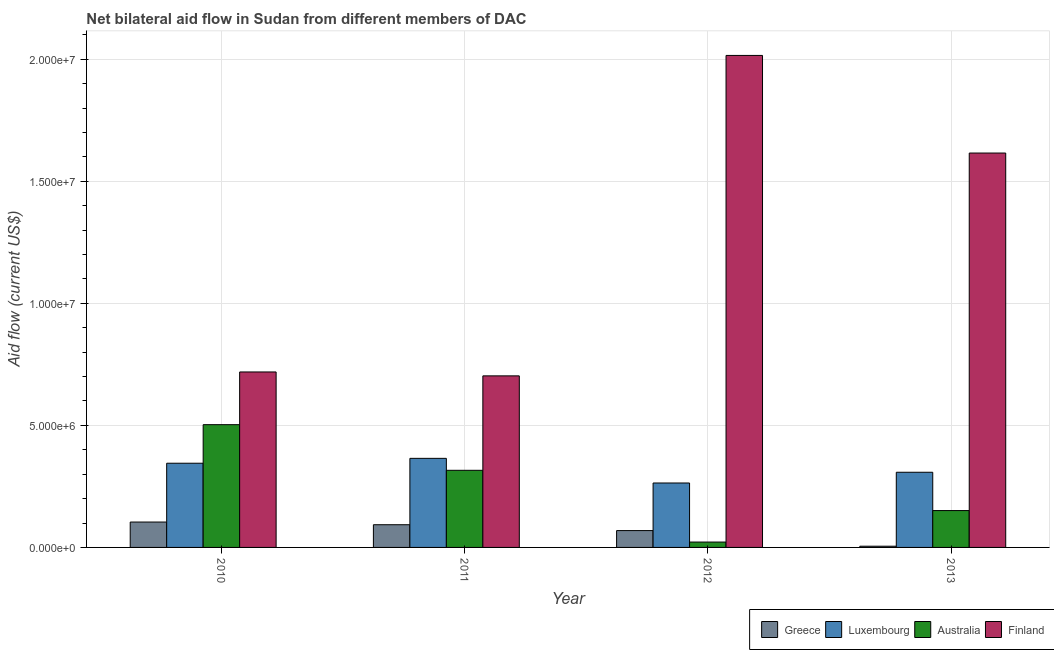How many different coloured bars are there?
Make the answer very short. 4. Are the number of bars on each tick of the X-axis equal?
Your response must be concise. Yes. In how many cases, is the number of bars for a given year not equal to the number of legend labels?
Provide a succinct answer. 0. What is the amount of aid given by australia in 2011?
Provide a succinct answer. 3.16e+06. Across all years, what is the maximum amount of aid given by luxembourg?
Ensure brevity in your answer.  3.65e+06. Across all years, what is the minimum amount of aid given by luxembourg?
Give a very brief answer. 2.64e+06. In which year was the amount of aid given by australia maximum?
Make the answer very short. 2010. In which year was the amount of aid given by luxembourg minimum?
Your answer should be compact. 2012. What is the total amount of aid given by greece in the graph?
Keep it short and to the point. 2.71e+06. What is the difference between the amount of aid given by greece in 2011 and that in 2012?
Your response must be concise. 2.40e+05. What is the difference between the amount of aid given by finland in 2013 and the amount of aid given by greece in 2012?
Your response must be concise. -4.00e+06. What is the average amount of aid given by luxembourg per year?
Your answer should be compact. 3.20e+06. In the year 2012, what is the difference between the amount of aid given by finland and amount of aid given by greece?
Keep it short and to the point. 0. What is the ratio of the amount of aid given by luxembourg in 2010 to that in 2013?
Keep it short and to the point. 1.12. Is the amount of aid given by luxembourg in 2010 less than that in 2011?
Your answer should be compact. Yes. Is the difference between the amount of aid given by greece in 2010 and 2013 greater than the difference between the amount of aid given by luxembourg in 2010 and 2013?
Ensure brevity in your answer.  No. What is the difference between the highest and the second highest amount of aid given by finland?
Offer a terse response. 4.00e+06. What is the difference between the highest and the lowest amount of aid given by luxembourg?
Your answer should be compact. 1.01e+06. In how many years, is the amount of aid given by greece greater than the average amount of aid given by greece taken over all years?
Ensure brevity in your answer.  3. Is the sum of the amount of aid given by luxembourg in 2012 and 2013 greater than the maximum amount of aid given by greece across all years?
Your answer should be very brief. Yes. Is it the case that in every year, the sum of the amount of aid given by finland and amount of aid given by greece is greater than the sum of amount of aid given by australia and amount of aid given by luxembourg?
Your response must be concise. Yes. What does the 4th bar from the right in 2013 represents?
Your answer should be very brief. Greece. Is it the case that in every year, the sum of the amount of aid given by greece and amount of aid given by luxembourg is greater than the amount of aid given by australia?
Offer a terse response. No. Are all the bars in the graph horizontal?
Your answer should be compact. No. How many years are there in the graph?
Offer a terse response. 4. What is the difference between two consecutive major ticks on the Y-axis?
Make the answer very short. 5.00e+06. Are the values on the major ticks of Y-axis written in scientific E-notation?
Offer a very short reply. Yes. Does the graph contain any zero values?
Offer a very short reply. No. Does the graph contain grids?
Give a very brief answer. Yes. How many legend labels are there?
Keep it short and to the point. 4. How are the legend labels stacked?
Give a very brief answer. Horizontal. What is the title of the graph?
Your answer should be very brief. Net bilateral aid flow in Sudan from different members of DAC. Does "UNPBF" appear as one of the legend labels in the graph?
Offer a terse response. No. What is the label or title of the X-axis?
Keep it short and to the point. Year. What is the label or title of the Y-axis?
Offer a terse response. Aid flow (current US$). What is the Aid flow (current US$) in Greece in 2010?
Offer a very short reply. 1.04e+06. What is the Aid flow (current US$) of Luxembourg in 2010?
Ensure brevity in your answer.  3.45e+06. What is the Aid flow (current US$) in Australia in 2010?
Provide a short and direct response. 5.03e+06. What is the Aid flow (current US$) of Finland in 2010?
Keep it short and to the point. 7.19e+06. What is the Aid flow (current US$) in Greece in 2011?
Make the answer very short. 9.30e+05. What is the Aid flow (current US$) in Luxembourg in 2011?
Provide a short and direct response. 3.65e+06. What is the Aid flow (current US$) in Australia in 2011?
Make the answer very short. 3.16e+06. What is the Aid flow (current US$) in Finland in 2011?
Give a very brief answer. 7.03e+06. What is the Aid flow (current US$) of Greece in 2012?
Keep it short and to the point. 6.90e+05. What is the Aid flow (current US$) of Luxembourg in 2012?
Provide a short and direct response. 2.64e+06. What is the Aid flow (current US$) in Finland in 2012?
Provide a short and direct response. 2.02e+07. What is the Aid flow (current US$) in Luxembourg in 2013?
Ensure brevity in your answer.  3.08e+06. What is the Aid flow (current US$) of Australia in 2013?
Ensure brevity in your answer.  1.51e+06. What is the Aid flow (current US$) of Finland in 2013?
Make the answer very short. 1.62e+07. Across all years, what is the maximum Aid flow (current US$) in Greece?
Ensure brevity in your answer.  1.04e+06. Across all years, what is the maximum Aid flow (current US$) of Luxembourg?
Your response must be concise. 3.65e+06. Across all years, what is the maximum Aid flow (current US$) of Australia?
Your answer should be compact. 5.03e+06. Across all years, what is the maximum Aid flow (current US$) in Finland?
Make the answer very short. 2.02e+07. Across all years, what is the minimum Aid flow (current US$) in Luxembourg?
Keep it short and to the point. 2.64e+06. Across all years, what is the minimum Aid flow (current US$) of Australia?
Ensure brevity in your answer.  2.20e+05. Across all years, what is the minimum Aid flow (current US$) in Finland?
Ensure brevity in your answer.  7.03e+06. What is the total Aid flow (current US$) of Greece in the graph?
Your answer should be very brief. 2.71e+06. What is the total Aid flow (current US$) of Luxembourg in the graph?
Your response must be concise. 1.28e+07. What is the total Aid flow (current US$) of Australia in the graph?
Make the answer very short. 9.92e+06. What is the total Aid flow (current US$) of Finland in the graph?
Provide a succinct answer. 5.05e+07. What is the difference between the Aid flow (current US$) of Australia in 2010 and that in 2011?
Provide a succinct answer. 1.87e+06. What is the difference between the Aid flow (current US$) in Greece in 2010 and that in 2012?
Provide a succinct answer. 3.50e+05. What is the difference between the Aid flow (current US$) of Luxembourg in 2010 and that in 2012?
Your response must be concise. 8.10e+05. What is the difference between the Aid flow (current US$) in Australia in 2010 and that in 2012?
Give a very brief answer. 4.81e+06. What is the difference between the Aid flow (current US$) of Finland in 2010 and that in 2012?
Offer a terse response. -1.30e+07. What is the difference between the Aid flow (current US$) of Greece in 2010 and that in 2013?
Keep it short and to the point. 9.90e+05. What is the difference between the Aid flow (current US$) in Australia in 2010 and that in 2013?
Give a very brief answer. 3.52e+06. What is the difference between the Aid flow (current US$) in Finland in 2010 and that in 2013?
Provide a short and direct response. -8.97e+06. What is the difference between the Aid flow (current US$) in Greece in 2011 and that in 2012?
Offer a very short reply. 2.40e+05. What is the difference between the Aid flow (current US$) of Luxembourg in 2011 and that in 2012?
Give a very brief answer. 1.01e+06. What is the difference between the Aid flow (current US$) of Australia in 2011 and that in 2012?
Your response must be concise. 2.94e+06. What is the difference between the Aid flow (current US$) of Finland in 2011 and that in 2012?
Offer a very short reply. -1.31e+07. What is the difference between the Aid flow (current US$) of Greece in 2011 and that in 2013?
Your response must be concise. 8.80e+05. What is the difference between the Aid flow (current US$) in Luxembourg in 2011 and that in 2013?
Ensure brevity in your answer.  5.70e+05. What is the difference between the Aid flow (current US$) in Australia in 2011 and that in 2013?
Give a very brief answer. 1.65e+06. What is the difference between the Aid flow (current US$) in Finland in 2011 and that in 2013?
Your response must be concise. -9.13e+06. What is the difference between the Aid flow (current US$) of Greece in 2012 and that in 2013?
Offer a very short reply. 6.40e+05. What is the difference between the Aid flow (current US$) of Luxembourg in 2012 and that in 2013?
Your answer should be very brief. -4.40e+05. What is the difference between the Aid flow (current US$) of Australia in 2012 and that in 2013?
Your answer should be compact. -1.29e+06. What is the difference between the Aid flow (current US$) of Greece in 2010 and the Aid flow (current US$) of Luxembourg in 2011?
Provide a short and direct response. -2.61e+06. What is the difference between the Aid flow (current US$) in Greece in 2010 and the Aid flow (current US$) in Australia in 2011?
Offer a very short reply. -2.12e+06. What is the difference between the Aid flow (current US$) of Greece in 2010 and the Aid flow (current US$) of Finland in 2011?
Make the answer very short. -5.99e+06. What is the difference between the Aid flow (current US$) in Luxembourg in 2010 and the Aid flow (current US$) in Finland in 2011?
Offer a terse response. -3.58e+06. What is the difference between the Aid flow (current US$) of Greece in 2010 and the Aid flow (current US$) of Luxembourg in 2012?
Your answer should be compact. -1.60e+06. What is the difference between the Aid flow (current US$) in Greece in 2010 and the Aid flow (current US$) in Australia in 2012?
Offer a very short reply. 8.20e+05. What is the difference between the Aid flow (current US$) of Greece in 2010 and the Aid flow (current US$) of Finland in 2012?
Keep it short and to the point. -1.91e+07. What is the difference between the Aid flow (current US$) in Luxembourg in 2010 and the Aid flow (current US$) in Australia in 2012?
Offer a very short reply. 3.23e+06. What is the difference between the Aid flow (current US$) of Luxembourg in 2010 and the Aid flow (current US$) of Finland in 2012?
Provide a short and direct response. -1.67e+07. What is the difference between the Aid flow (current US$) of Australia in 2010 and the Aid flow (current US$) of Finland in 2012?
Make the answer very short. -1.51e+07. What is the difference between the Aid flow (current US$) in Greece in 2010 and the Aid flow (current US$) in Luxembourg in 2013?
Give a very brief answer. -2.04e+06. What is the difference between the Aid flow (current US$) in Greece in 2010 and the Aid flow (current US$) in Australia in 2013?
Keep it short and to the point. -4.70e+05. What is the difference between the Aid flow (current US$) in Greece in 2010 and the Aid flow (current US$) in Finland in 2013?
Offer a terse response. -1.51e+07. What is the difference between the Aid flow (current US$) in Luxembourg in 2010 and the Aid flow (current US$) in Australia in 2013?
Provide a succinct answer. 1.94e+06. What is the difference between the Aid flow (current US$) of Luxembourg in 2010 and the Aid flow (current US$) of Finland in 2013?
Keep it short and to the point. -1.27e+07. What is the difference between the Aid flow (current US$) of Australia in 2010 and the Aid flow (current US$) of Finland in 2013?
Give a very brief answer. -1.11e+07. What is the difference between the Aid flow (current US$) of Greece in 2011 and the Aid flow (current US$) of Luxembourg in 2012?
Your response must be concise. -1.71e+06. What is the difference between the Aid flow (current US$) of Greece in 2011 and the Aid flow (current US$) of Australia in 2012?
Give a very brief answer. 7.10e+05. What is the difference between the Aid flow (current US$) of Greece in 2011 and the Aid flow (current US$) of Finland in 2012?
Ensure brevity in your answer.  -1.92e+07. What is the difference between the Aid flow (current US$) of Luxembourg in 2011 and the Aid flow (current US$) of Australia in 2012?
Offer a terse response. 3.43e+06. What is the difference between the Aid flow (current US$) of Luxembourg in 2011 and the Aid flow (current US$) of Finland in 2012?
Make the answer very short. -1.65e+07. What is the difference between the Aid flow (current US$) in Australia in 2011 and the Aid flow (current US$) in Finland in 2012?
Your answer should be compact. -1.70e+07. What is the difference between the Aid flow (current US$) of Greece in 2011 and the Aid flow (current US$) of Luxembourg in 2013?
Offer a very short reply. -2.15e+06. What is the difference between the Aid flow (current US$) of Greece in 2011 and the Aid flow (current US$) of Australia in 2013?
Offer a very short reply. -5.80e+05. What is the difference between the Aid flow (current US$) of Greece in 2011 and the Aid flow (current US$) of Finland in 2013?
Offer a terse response. -1.52e+07. What is the difference between the Aid flow (current US$) of Luxembourg in 2011 and the Aid flow (current US$) of Australia in 2013?
Provide a succinct answer. 2.14e+06. What is the difference between the Aid flow (current US$) of Luxembourg in 2011 and the Aid flow (current US$) of Finland in 2013?
Your answer should be very brief. -1.25e+07. What is the difference between the Aid flow (current US$) in Australia in 2011 and the Aid flow (current US$) in Finland in 2013?
Provide a succinct answer. -1.30e+07. What is the difference between the Aid flow (current US$) of Greece in 2012 and the Aid flow (current US$) of Luxembourg in 2013?
Ensure brevity in your answer.  -2.39e+06. What is the difference between the Aid flow (current US$) of Greece in 2012 and the Aid flow (current US$) of Australia in 2013?
Keep it short and to the point. -8.20e+05. What is the difference between the Aid flow (current US$) in Greece in 2012 and the Aid flow (current US$) in Finland in 2013?
Ensure brevity in your answer.  -1.55e+07. What is the difference between the Aid flow (current US$) of Luxembourg in 2012 and the Aid flow (current US$) of Australia in 2013?
Keep it short and to the point. 1.13e+06. What is the difference between the Aid flow (current US$) in Luxembourg in 2012 and the Aid flow (current US$) in Finland in 2013?
Provide a short and direct response. -1.35e+07. What is the difference between the Aid flow (current US$) of Australia in 2012 and the Aid flow (current US$) of Finland in 2013?
Keep it short and to the point. -1.59e+07. What is the average Aid flow (current US$) of Greece per year?
Your answer should be very brief. 6.78e+05. What is the average Aid flow (current US$) in Luxembourg per year?
Provide a short and direct response. 3.20e+06. What is the average Aid flow (current US$) of Australia per year?
Your response must be concise. 2.48e+06. What is the average Aid flow (current US$) in Finland per year?
Offer a terse response. 1.26e+07. In the year 2010, what is the difference between the Aid flow (current US$) in Greece and Aid flow (current US$) in Luxembourg?
Ensure brevity in your answer.  -2.41e+06. In the year 2010, what is the difference between the Aid flow (current US$) in Greece and Aid flow (current US$) in Australia?
Ensure brevity in your answer.  -3.99e+06. In the year 2010, what is the difference between the Aid flow (current US$) of Greece and Aid flow (current US$) of Finland?
Ensure brevity in your answer.  -6.15e+06. In the year 2010, what is the difference between the Aid flow (current US$) of Luxembourg and Aid flow (current US$) of Australia?
Your answer should be compact. -1.58e+06. In the year 2010, what is the difference between the Aid flow (current US$) in Luxembourg and Aid flow (current US$) in Finland?
Provide a short and direct response. -3.74e+06. In the year 2010, what is the difference between the Aid flow (current US$) of Australia and Aid flow (current US$) of Finland?
Your response must be concise. -2.16e+06. In the year 2011, what is the difference between the Aid flow (current US$) of Greece and Aid flow (current US$) of Luxembourg?
Provide a short and direct response. -2.72e+06. In the year 2011, what is the difference between the Aid flow (current US$) of Greece and Aid flow (current US$) of Australia?
Your answer should be compact. -2.23e+06. In the year 2011, what is the difference between the Aid flow (current US$) in Greece and Aid flow (current US$) in Finland?
Ensure brevity in your answer.  -6.10e+06. In the year 2011, what is the difference between the Aid flow (current US$) in Luxembourg and Aid flow (current US$) in Finland?
Give a very brief answer. -3.38e+06. In the year 2011, what is the difference between the Aid flow (current US$) of Australia and Aid flow (current US$) of Finland?
Offer a terse response. -3.87e+06. In the year 2012, what is the difference between the Aid flow (current US$) of Greece and Aid flow (current US$) of Luxembourg?
Your response must be concise. -1.95e+06. In the year 2012, what is the difference between the Aid flow (current US$) of Greece and Aid flow (current US$) of Australia?
Provide a short and direct response. 4.70e+05. In the year 2012, what is the difference between the Aid flow (current US$) of Greece and Aid flow (current US$) of Finland?
Provide a short and direct response. -1.95e+07. In the year 2012, what is the difference between the Aid flow (current US$) in Luxembourg and Aid flow (current US$) in Australia?
Your answer should be compact. 2.42e+06. In the year 2012, what is the difference between the Aid flow (current US$) in Luxembourg and Aid flow (current US$) in Finland?
Ensure brevity in your answer.  -1.75e+07. In the year 2012, what is the difference between the Aid flow (current US$) in Australia and Aid flow (current US$) in Finland?
Keep it short and to the point. -1.99e+07. In the year 2013, what is the difference between the Aid flow (current US$) in Greece and Aid flow (current US$) in Luxembourg?
Provide a short and direct response. -3.03e+06. In the year 2013, what is the difference between the Aid flow (current US$) in Greece and Aid flow (current US$) in Australia?
Your answer should be very brief. -1.46e+06. In the year 2013, what is the difference between the Aid flow (current US$) of Greece and Aid flow (current US$) of Finland?
Offer a terse response. -1.61e+07. In the year 2013, what is the difference between the Aid flow (current US$) of Luxembourg and Aid flow (current US$) of Australia?
Provide a succinct answer. 1.57e+06. In the year 2013, what is the difference between the Aid flow (current US$) of Luxembourg and Aid flow (current US$) of Finland?
Provide a succinct answer. -1.31e+07. In the year 2013, what is the difference between the Aid flow (current US$) of Australia and Aid flow (current US$) of Finland?
Offer a terse response. -1.46e+07. What is the ratio of the Aid flow (current US$) in Greece in 2010 to that in 2011?
Offer a very short reply. 1.12. What is the ratio of the Aid flow (current US$) in Luxembourg in 2010 to that in 2011?
Make the answer very short. 0.95. What is the ratio of the Aid flow (current US$) in Australia in 2010 to that in 2011?
Provide a succinct answer. 1.59. What is the ratio of the Aid flow (current US$) of Finland in 2010 to that in 2011?
Your response must be concise. 1.02. What is the ratio of the Aid flow (current US$) in Greece in 2010 to that in 2012?
Keep it short and to the point. 1.51. What is the ratio of the Aid flow (current US$) of Luxembourg in 2010 to that in 2012?
Keep it short and to the point. 1.31. What is the ratio of the Aid flow (current US$) of Australia in 2010 to that in 2012?
Provide a short and direct response. 22.86. What is the ratio of the Aid flow (current US$) in Finland in 2010 to that in 2012?
Your answer should be very brief. 0.36. What is the ratio of the Aid flow (current US$) in Greece in 2010 to that in 2013?
Ensure brevity in your answer.  20.8. What is the ratio of the Aid flow (current US$) in Luxembourg in 2010 to that in 2013?
Offer a very short reply. 1.12. What is the ratio of the Aid flow (current US$) in Australia in 2010 to that in 2013?
Provide a short and direct response. 3.33. What is the ratio of the Aid flow (current US$) in Finland in 2010 to that in 2013?
Your answer should be very brief. 0.44. What is the ratio of the Aid flow (current US$) of Greece in 2011 to that in 2012?
Make the answer very short. 1.35. What is the ratio of the Aid flow (current US$) of Luxembourg in 2011 to that in 2012?
Give a very brief answer. 1.38. What is the ratio of the Aid flow (current US$) of Australia in 2011 to that in 2012?
Your response must be concise. 14.36. What is the ratio of the Aid flow (current US$) in Finland in 2011 to that in 2012?
Your answer should be very brief. 0.35. What is the ratio of the Aid flow (current US$) of Greece in 2011 to that in 2013?
Your answer should be compact. 18.6. What is the ratio of the Aid flow (current US$) in Luxembourg in 2011 to that in 2013?
Make the answer very short. 1.19. What is the ratio of the Aid flow (current US$) in Australia in 2011 to that in 2013?
Offer a terse response. 2.09. What is the ratio of the Aid flow (current US$) of Finland in 2011 to that in 2013?
Your response must be concise. 0.43. What is the ratio of the Aid flow (current US$) of Luxembourg in 2012 to that in 2013?
Your response must be concise. 0.86. What is the ratio of the Aid flow (current US$) of Australia in 2012 to that in 2013?
Offer a very short reply. 0.15. What is the ratio of the Aid flow (current US$) in Finland in 2012 to that in 2013?
Provide a succinct answer. 1.25. What is the difference between the highest and the second highest Aid flow (current US$) of Greece?
Your answer should be compact. 1.10e+05. What is the difference between the highest and the second highest Aid flow (current US$) in Luxembourg?
Keep it short and to the point. 2.00e+05. What is the difference between the highest and the second highest Aid flow (current US$) in Australia?
Your answer should be compact. 1.87e+06. What is the difference between the highest and the second highest Aid flow (current US$) of Finland?
Provide a short and direct response. 4.00e+06. What is the difference between the highest and the lowest Aid flow (current US$) in Greece?
Your answer should be compact. 9.90e+05. What is the difference between the highest and the lowest Aid flow (current US$) in Luxembourg?
Make the answer very short. 1.01e+06. What is the difference between the highest and the lowest Aid flow (current US$) of Australia?
Offer a very short reply. 4.81e+06. What is the difference between the highest and the lowest Aid flow (current US$) of Finland?
Make the answer very short. 1.31e+07. 